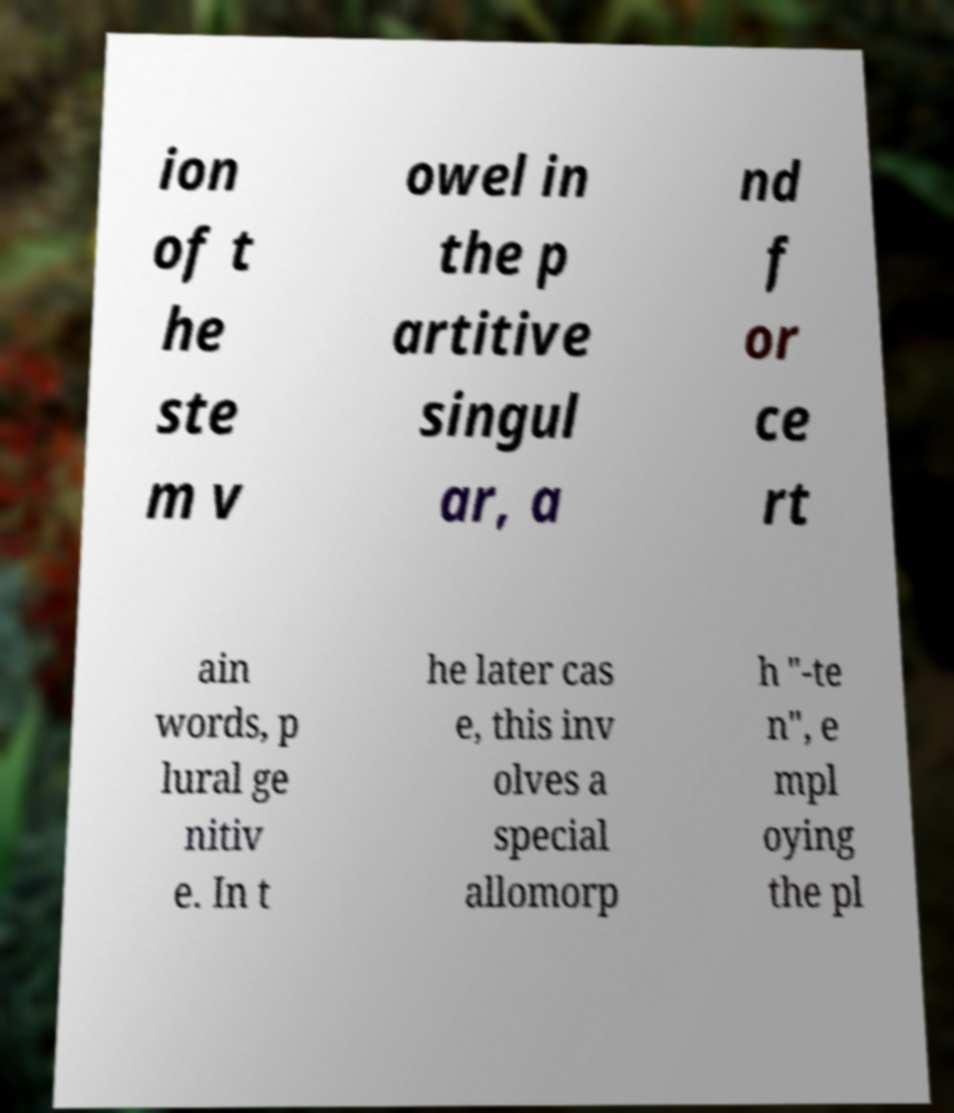Please read and relay the text visible in this image. What does it say? ion of t he ste m v owel in the p artitive singul ar, a nd f or ce rt ain words, p lural ge nitiv e. In t he later cas e, this inv olves a special allomorp h "-te n", e mpl oying the pl 